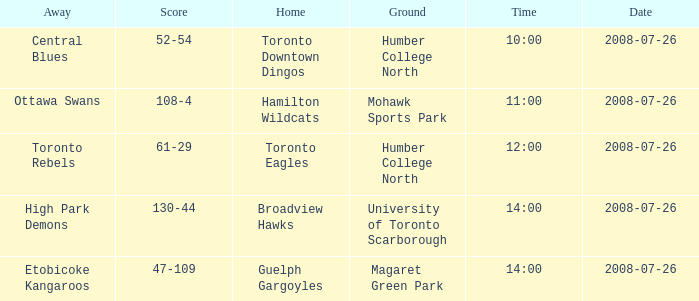The Away High Park Demons was which Ground? University of Toronto Scarborough. 